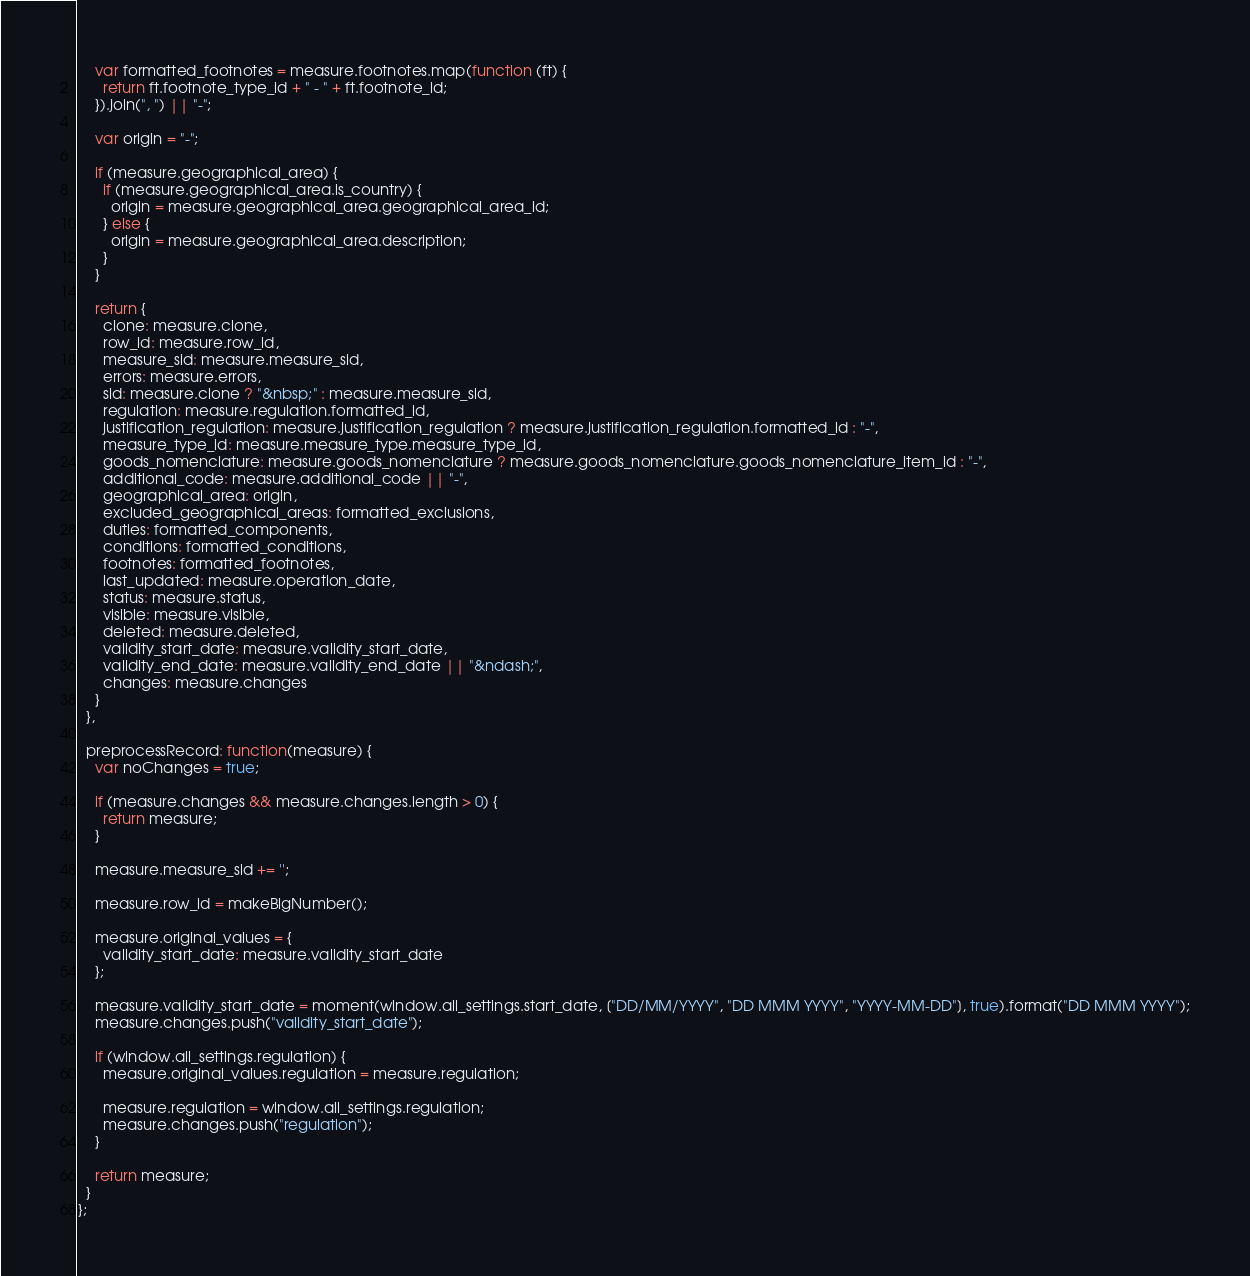<code> <loc_0><loc_0><loc_500><loc_500><_JavaScript_>    var formatted_footnotes = measure.footnotes.map(function (ft) {
      return ft.footnote_type_id + " - " + ft.footnote_id;
    }).join(", ") || "-";

    var origin = "-";

    if (measure.geographical_area) {
      if (measure.geographical_area.is_country) {
        origin = measure.geographical_area.geographical_area_id;
      } else {
        origin = measure.geographical_area.description;
      }
    }

    return {
      clone: measure.clone,
      row_id: measure.row_id,
      measure_sid: measure.measure_sid,
      errors: measure.errors,
      sid: measure.clone ? "&nbsp;" : measure.measure_sid,
      regulation: measure.regulation.formatted_id,
      justification_regulation: measure.justification_regulation ? measure.justification_regulation.formatted_id : "-",
      measure_type_id: measure.measure_type.measure_type_id,
      goods_nomenclature: measure.goods_nomenclature ? measure.goods_nomenclature.goods_nomenclature_item_id : "-",
      additional_code: measure.additional_code || "-",
      geographical_area: origin,
      excluded_geographical_areas: formatted_exclusions,
      duties: formatted_components,
      conditions: formatted_conditions,
      footnotes: formatted_footnotes,
      last_updated: measure.operation_date,
      status: measure.status,
      visible: measure.visible,
      deleted: measure.deleted,
      validity_start_date: measure.validity_start_date,
      validity_end_date: measure.validity_end_date || "&ndash;",
      changes: measure.changes
    }
  },

  preprocessRecord: function(measure) {
    var noChanges = true;

    if (measure.changes && measure.changes.length > 0) {
      return measure;
    }

    measure.measure_sid += '';

    measure.row_id = makeBigNumber();

    measure.original_values = {
      validity_start_date: measure.validity_start_date
    };

    measure.validity_start_date = moment(window.all_settings.start_date, ["DD/MM/YYYY", "DD MMM YYYY", "YYYY-MM-DD"], true).format("DD MMM YYYY");
    measure.changes.push("validity_start_date");

    if (window.all_settings.regulation) {
      measure.original_values.regulation = measure.regulation;

      measure.regulation = window.all_settings.regulation;
      measure.changes.push("regulation");
    }

    return measure;
  }
};
</code> 